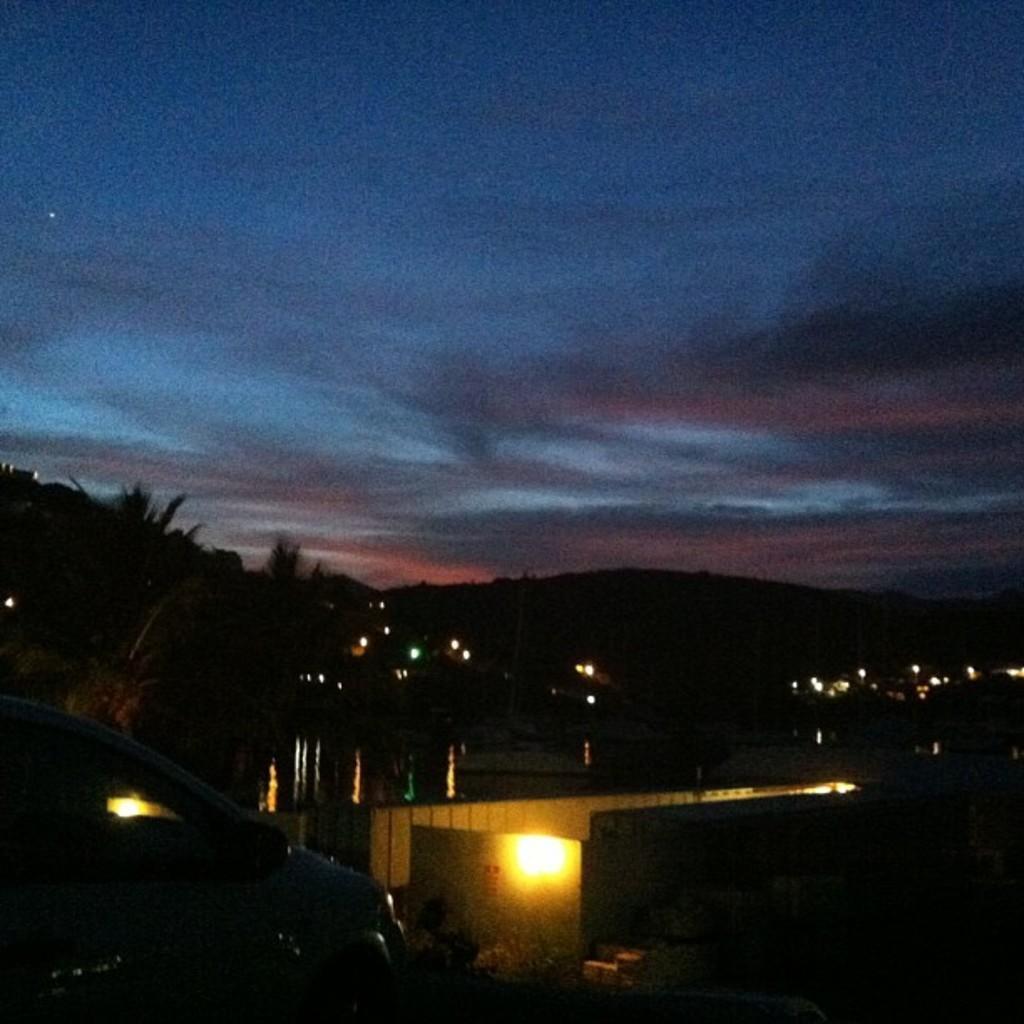Can you describe this image briefly? Here there are trees, this is car, this is light, where there is blue color sky. 